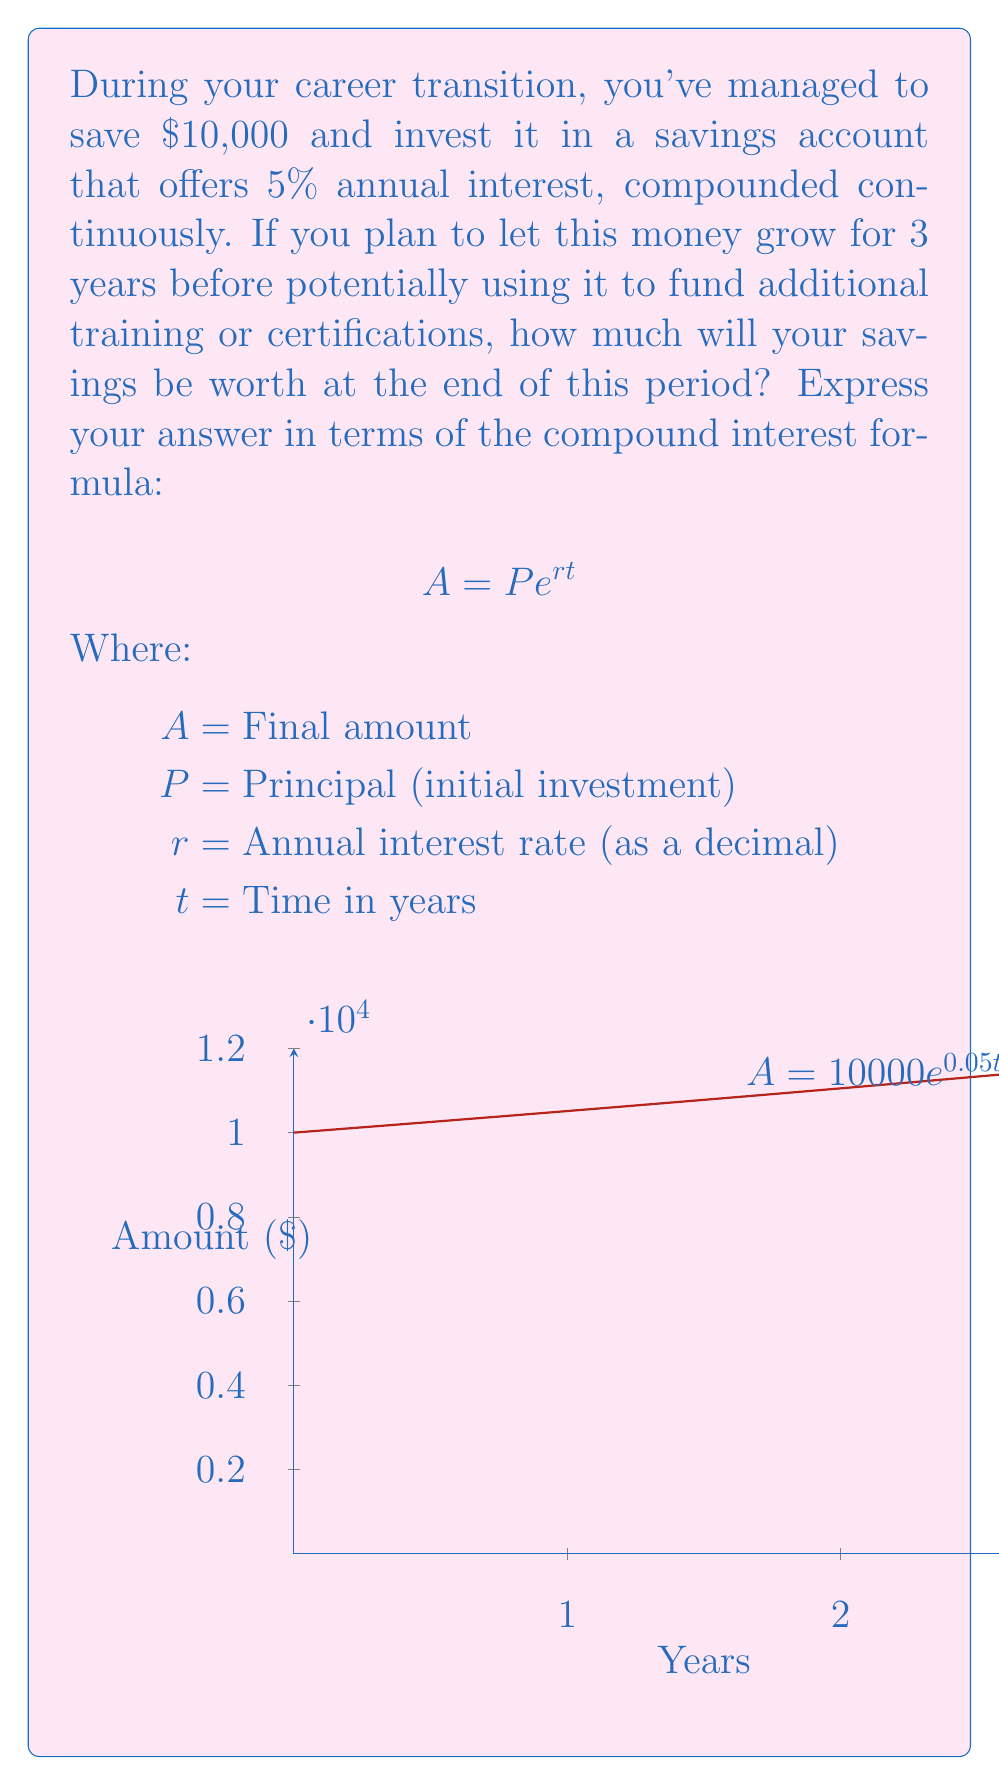Give your solution to this math problem. To solve this problem, we'll use the compound interest formula for continuous compounding:

$$A = P e^{rt}$$

Given:
$P = 10,000$ (initial investment)
$r = 0.05$ (5% annual interest rate as a decimal)
$t = 3$ years

Let's substitute these values into the formula:

$$A = 10,000 \cdot e^{0.05 \cdot 3}$$

Now, let's calculate:

1) First, multiply the exponent:
   $$A = 10,000 \cdot e^{0.15}$$

2) Calculate $e^{0.15}$ (you can use a calculator for this):
   $$e^{0.15} \approx 1.1618$$

3) Multiply this by the initial investment:
   $$A = 10,000 \cdot 1.1618 = 11,618$$

Therefore, after 3 years, your savings will grow to approximately $11,618.
Answer: $A = 10,000 \cdot e^{0.15} \approx 11,618$ 